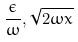<formula> <loc_0><loc_0><loc_500><loc_500>\frac { \epsilon } { \omega } , \sqrt { 2 \omega x }</formula> 